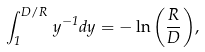<formula> <loc_0><loc_0><loc_500><loc_500>\int _ { 1 } ^ { D / R } \, y ^ { - 1 } d y = - \ln { \left ( \frac { R } { D } \right ) } ,</formula> 